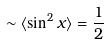Convert formula to latex. <formula><loc_0><loc_0><loc_500><loc_500>\sim \langle \sin ^ { 2 } x \rangle = \frac { 1 } { 2 }</formula> 